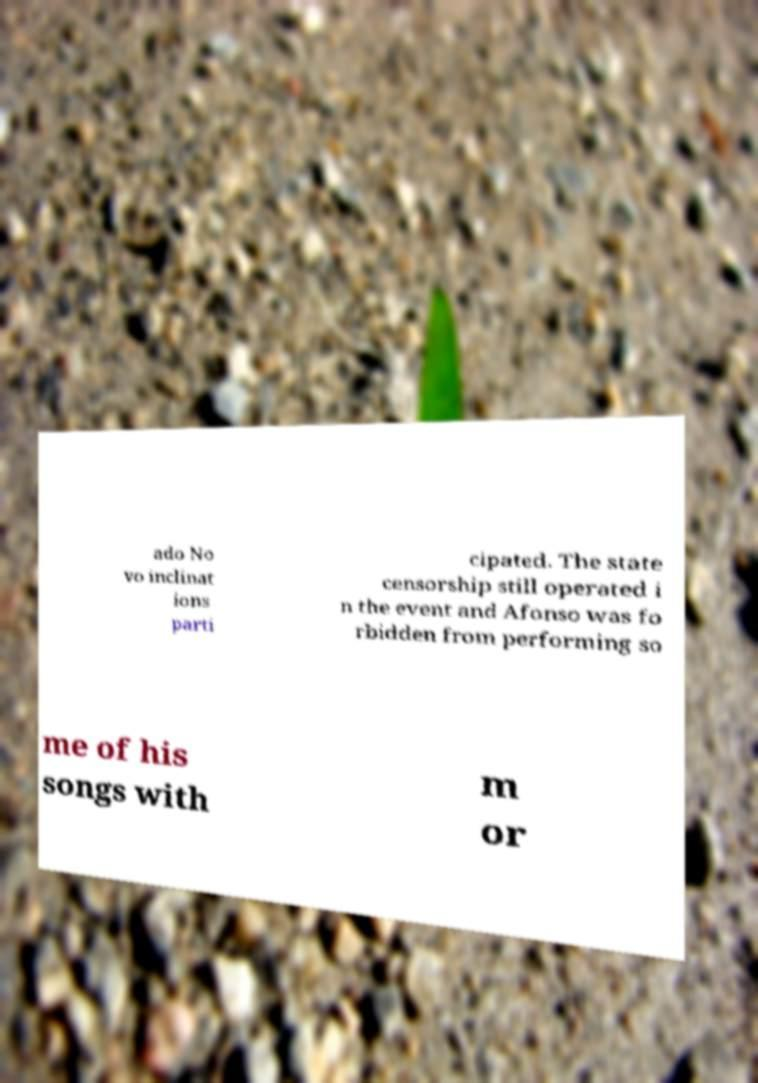There's text embedded in this image that I need extracted. Can you transcribe it verbatim? ado No vo inclinat ions parti cipated. The state censorship still operated i n the event and Afonso was fo rbidden from performing so me of his songs with m or 